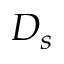Convert formula to latex. <formula><loc_0><loc_0><loc_500><loc_500>D _ { s }</formula> 